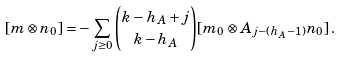<formula> <loc_0><loc_0><loc_500><loc_500>[ m \otimes n _ { 0 } ] = - \sum _ { j \geq 0 } \binom { k - h _ { A } + j } { k - h _ { A } } [ m _ { 0 } \otimes A _ { j - ( h _ { A } - 1 ) } n _ { 0 } ] \, .</formula> 